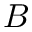Convert formula to latex. <formula><loc_0><loc_0><loc_500><loc_500>B</formula> 